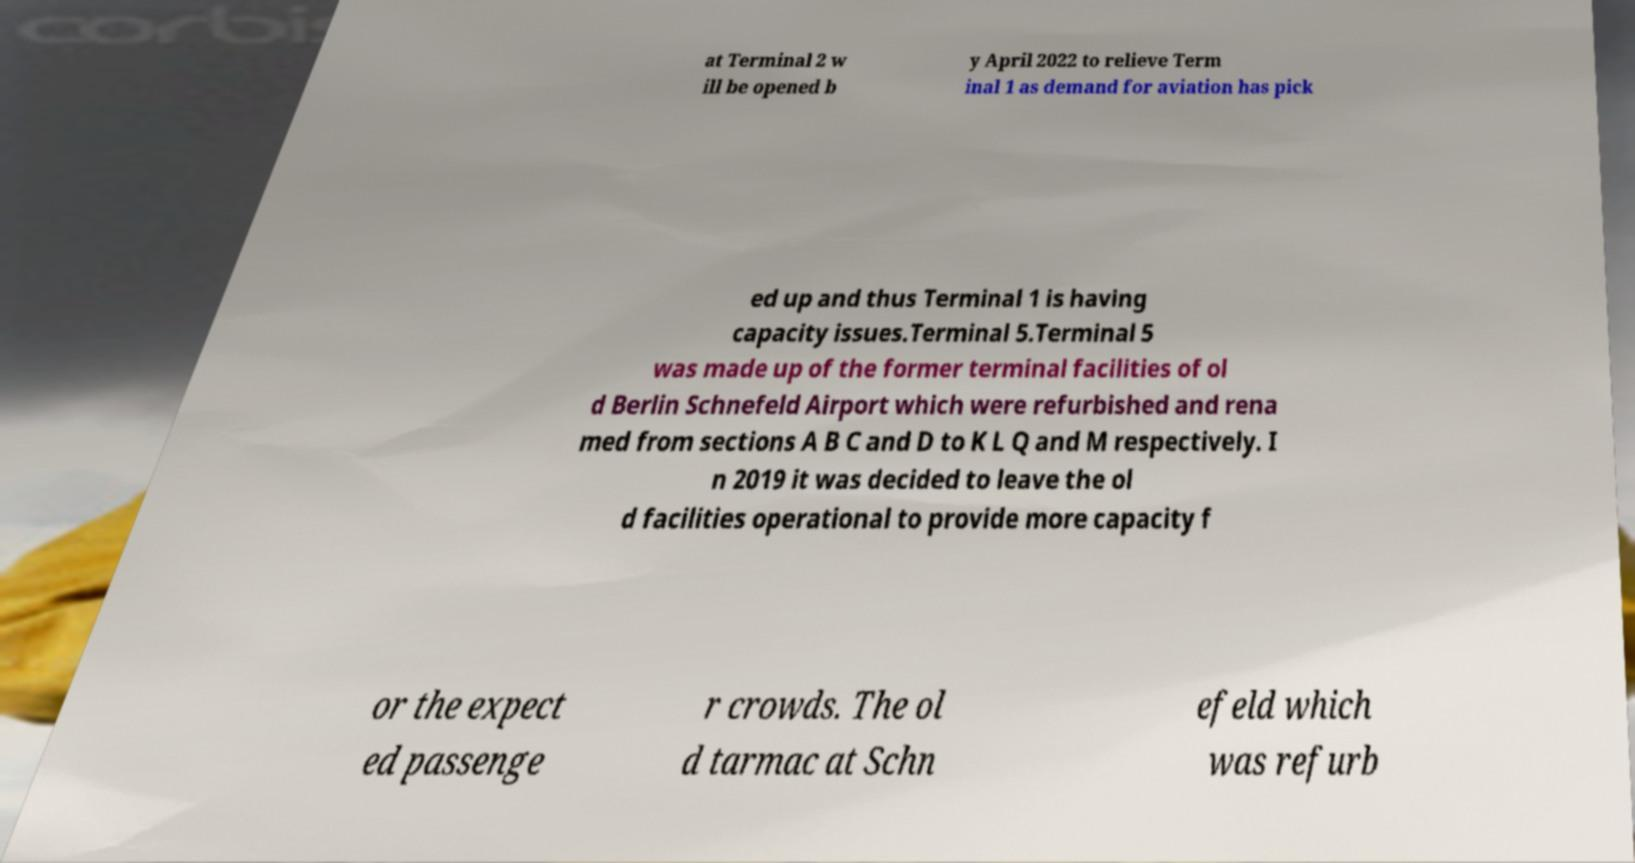Can you read and provide the text displayed in the image?This photo seems to have some interesting text. Can you extract and type it out for me? at Terminal 2 w ill be opened b y April 2022 to relieve Term inal 1 as demand for aviation has pick ed up and thus Terminal 1 is having capacity issues.Terminal 5.Terminal 5 was made up of the former terminal facilities of ol d Berlin Schnefeld Airport which were refurbished and rena med from sections A B C and D to K L Q and M respectively. I n 2019 it was decided to leave the ol d facilities operational to provide more capacity f or the expect ed passenge r crowds. The ol d tarmac at Schn efeld which was refurb 